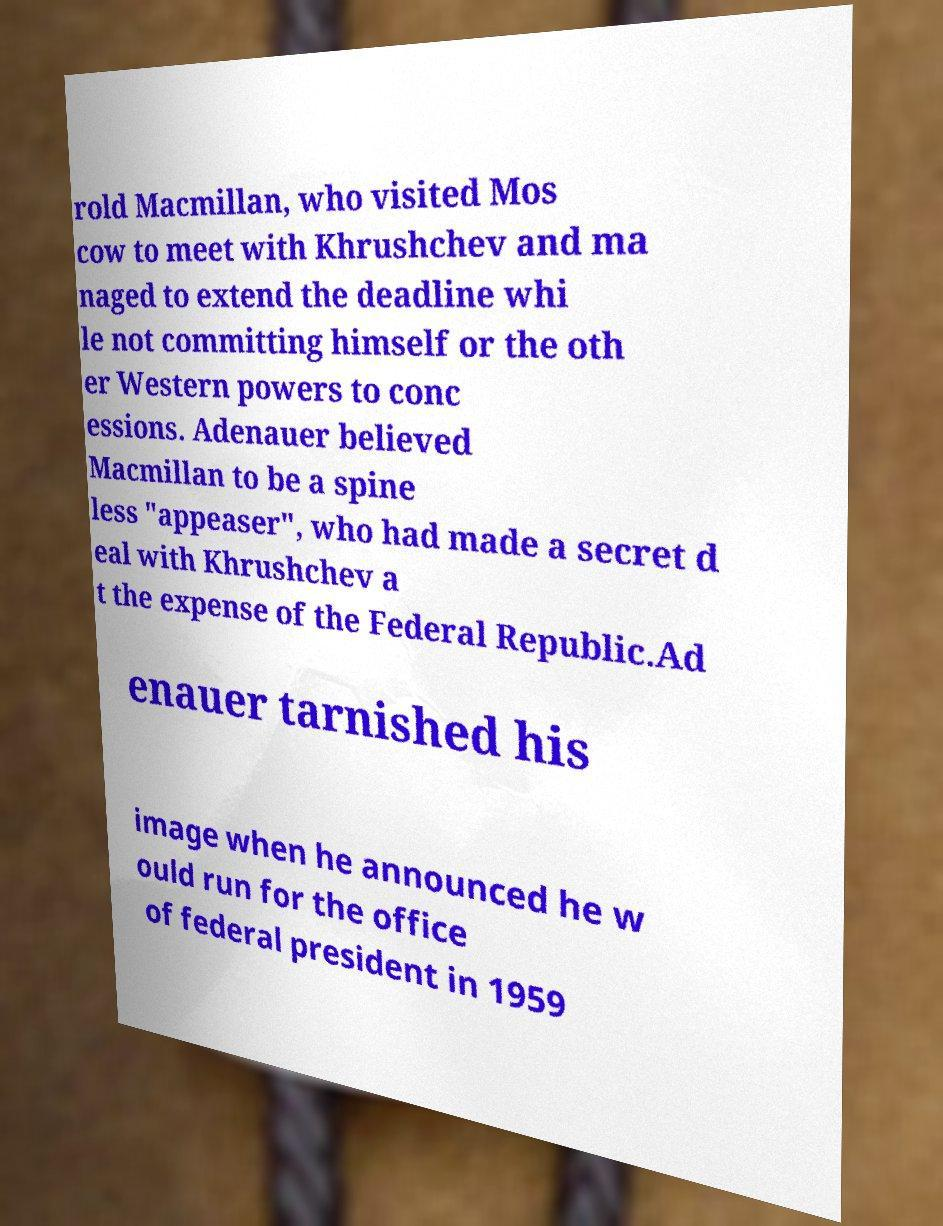Please read and relay the text visible in this image. What does it say? rold Macmillan, who visited Mos cow to meet with Khrushchev and ma naged to extend the deadline whi le not committing himself or the oth er Western powers to conc essions. Adenauer believed Macmillan to be a spine less "appeaser", who had made a secret d eal with Khrushchev a t the expense of the Federal Republic.Ad enauer tarnished his image when he announced he w ould run for the office of federal president in 1959 